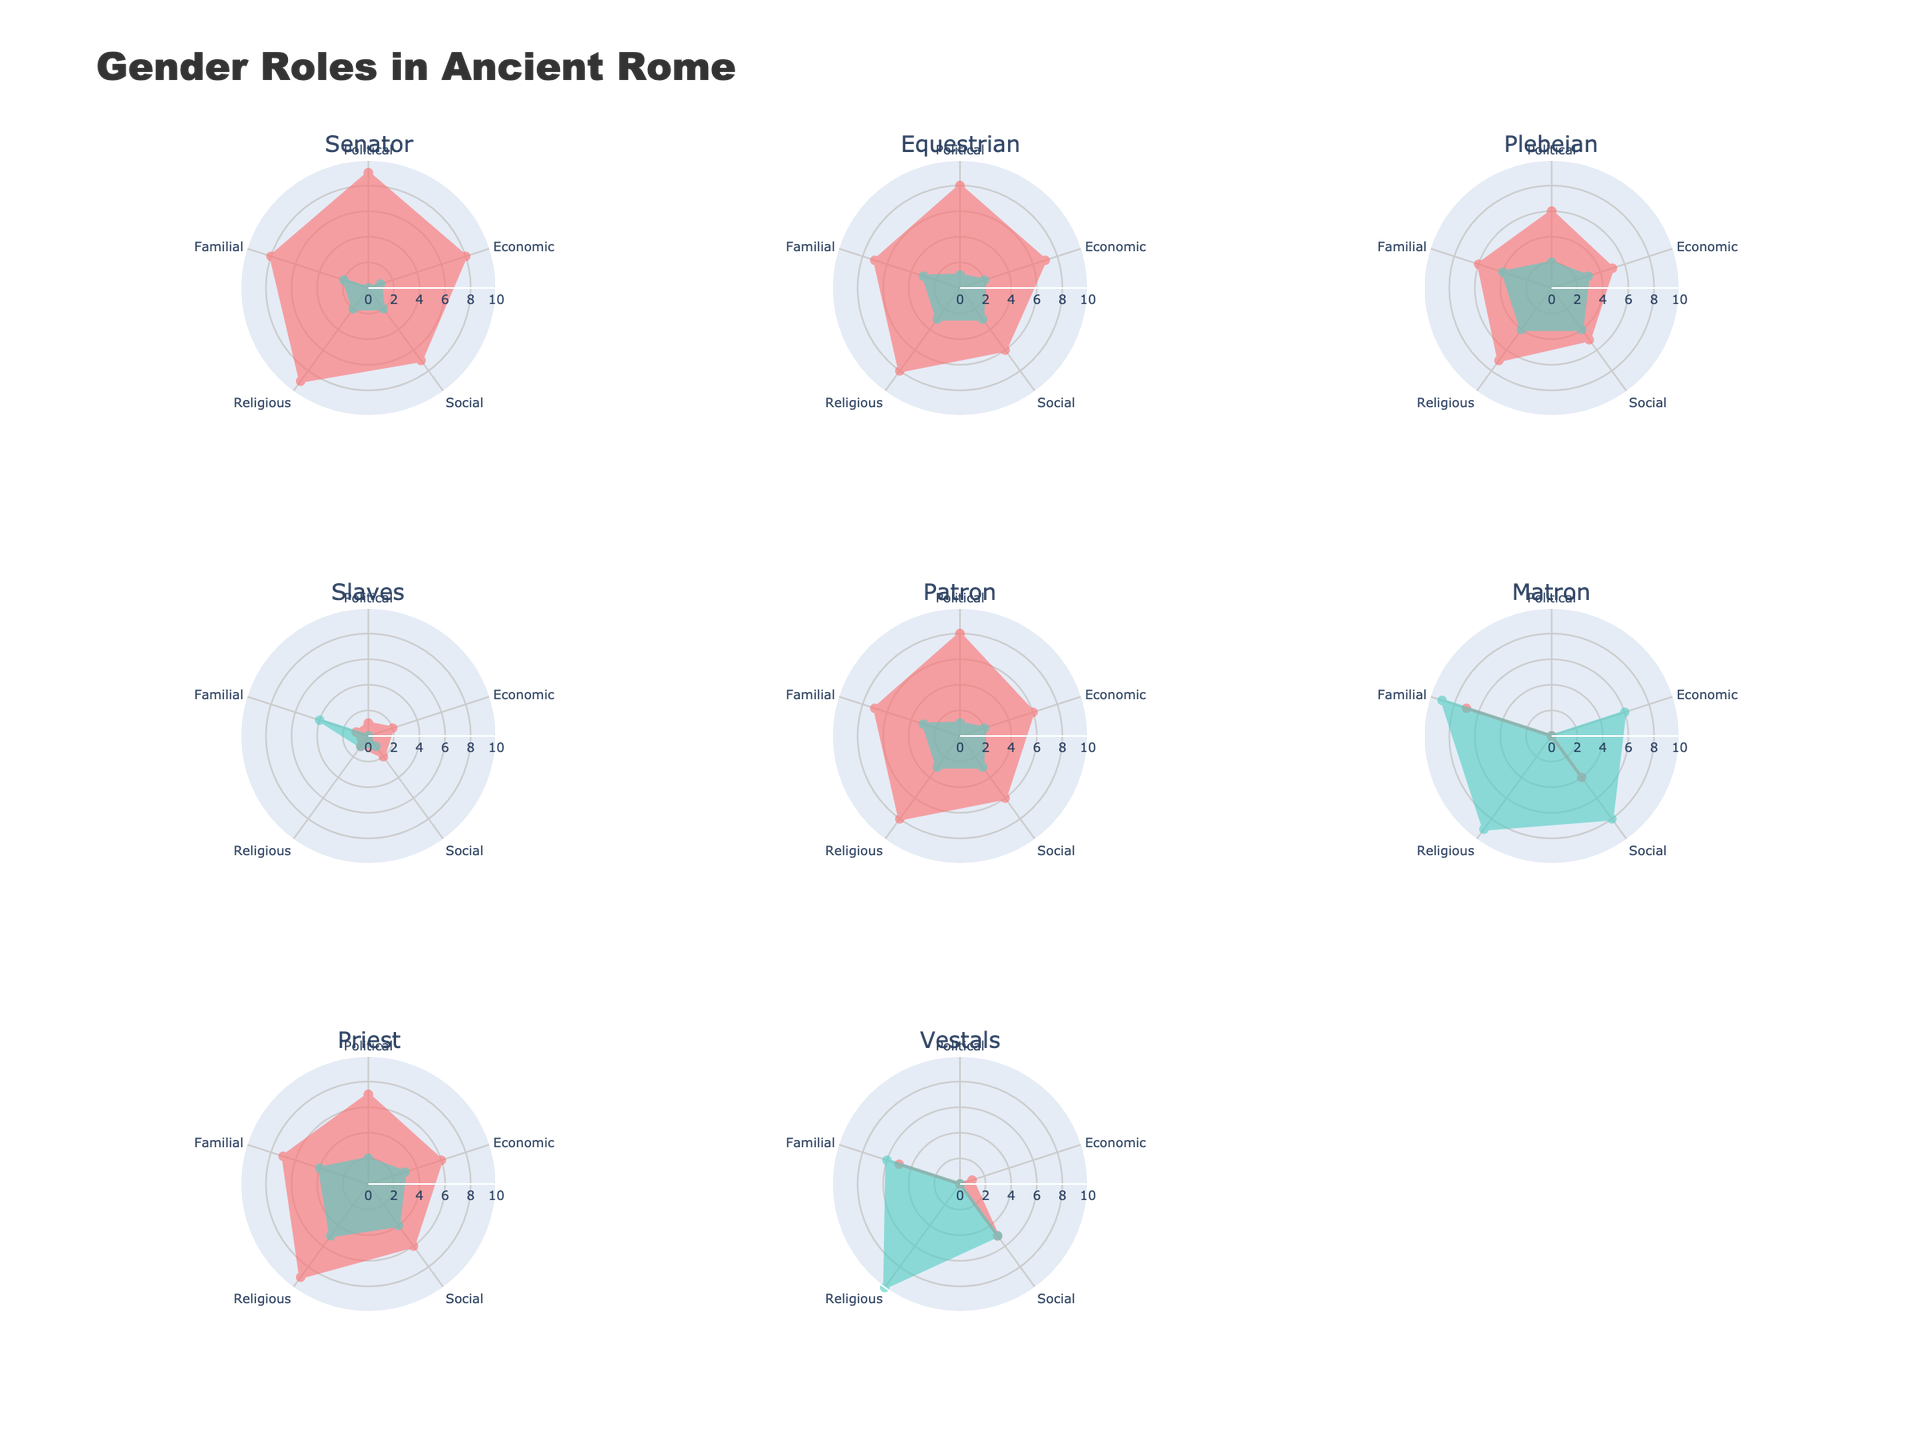Who has the highest level of political power among men? By looking at the subplot for each role, we identify the role with the longest distance for "Political" power for men. In this case, it’s the "Senator" role, as it has the maximum value for men.
Answer: Senator Which category shows the smallest difference in power between men and women for equestrians? By comparing the values of each power category for men and women in the equestrian subplot, we see that the smallest difference occurs in the "Social" category. Men have a value of 6 and women 3, making the difference 3. Other categories have larger differences.
Answer: Social What is the combined familial power of male senators and male priests? Summing the "Familial" power values from the "Senator" subplot (8) and the "Priest" subplot (7) gives us 8 + 7.
Answer: 15 Which group has a higher economic power value, plebeian women or matron women? We directly compare the "Economic" values for women in the plebeian and matron subplots. The plebeian women have 3, while matron women have 0. Therefore, plebeian women have a higher value.
Answer: Plebeian women What is the average social power for male equestrians, plebeians, and slaves? To find the average, sum the "Social" power values for male equestrians (6), plebeians (5), and slaves (2). Then divide by 3: (6 + 5 + 2)/3 = 13/3 ≈ 4.33.
Answer: 4.33 Which category has the highest power for female vestals? By examining the radar chart subplot for vestals, the category with the highest power for women is "Religious," with a value of 10.
Answer: Religious Compare the political power between male patrons and male plebeians. Who is more powerful? The "Political" power value for male patrons is 8, and for male plebeians, it is 6. Therefore, male patrons have more political power.
Answer: Male patrons What familial power value difference exists between male and female slaves? For the "Familial" category, male slaves have a value of 1 and female slaves have a value of 4. The difference is 4 - 1 = 3.
Answer: 3 